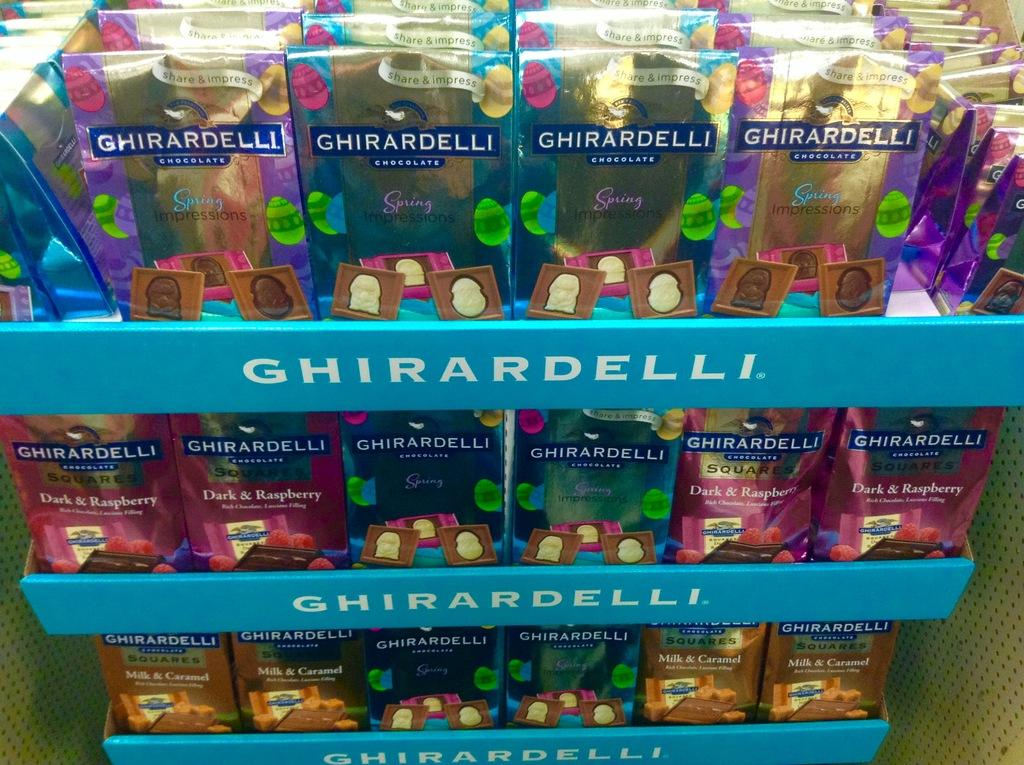<image>
Provide a brief description of the given image. a Ghirardelli chocolate display has three levesl of chocolate on it 